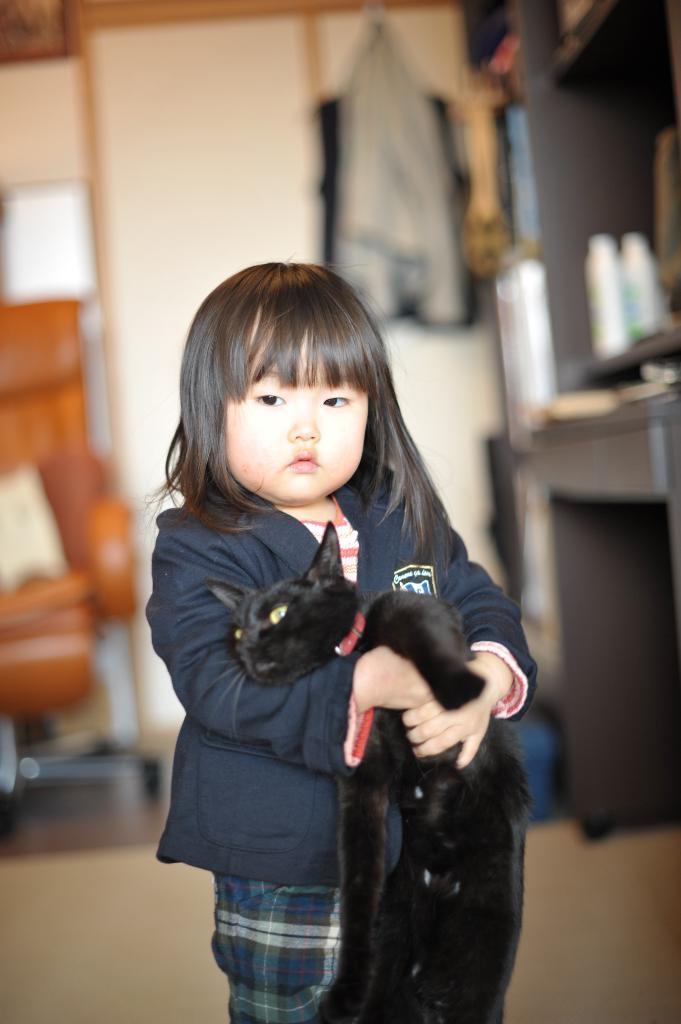Please provide a concise description of this image. This is the picture of a little girl wearing a blue color jacket and holding a black color cat in her hand. 